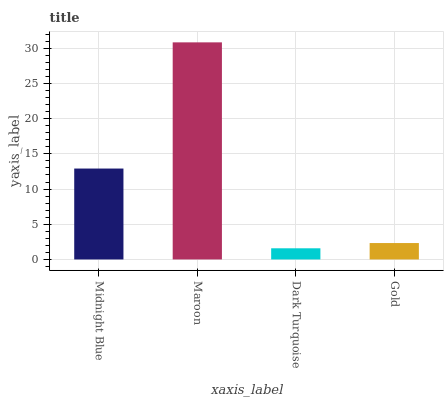Is Maroon the minimum?
Answer yes or no. No. Is Dark Turquoise the maximum?
Answer yes or no. No. Is Maroon greater than Dark Turquoise?
Answer yes or no. Yes. Is Dark Turquoise less than Maroon?
Answer yes or no. Yes. Is Dark Turquoise greater than Maroon?
Answer yes or no. No. Is Maroon less than Dark Turquoise?
Answer yes or no. No. Is Midnight Blue the high median?
Answer yes or no. Yes. Is Gold the low median?
Answer yes or no. Yes. Is Gold the high median?
Answer yes or no. No. Is Dark Turquoise the low median?
Answer yes or no. No. 